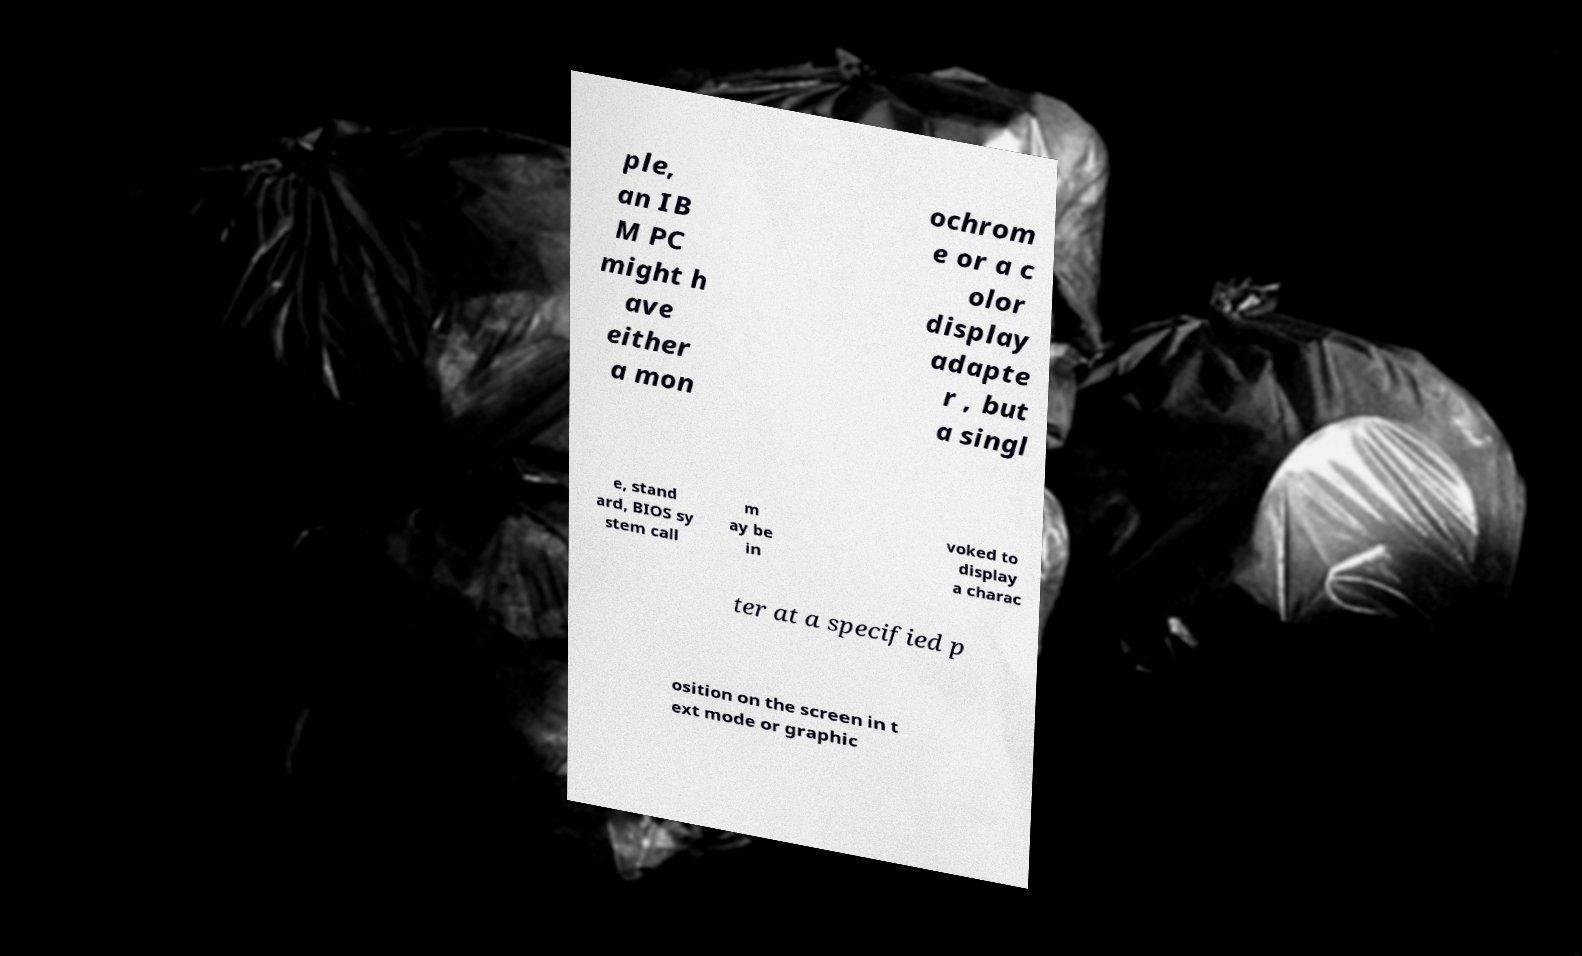For documentation purposes, I need the text within this image transcribed. Could you provide that? ple, an IB M PC might h ave either a mon ochrom e or a c olor display adapte r , but a singl e, stand ard, BIOS sy stem call m ay be in voked to display a charac ter at a specified p osition on the screen in t ext mode or graphic 